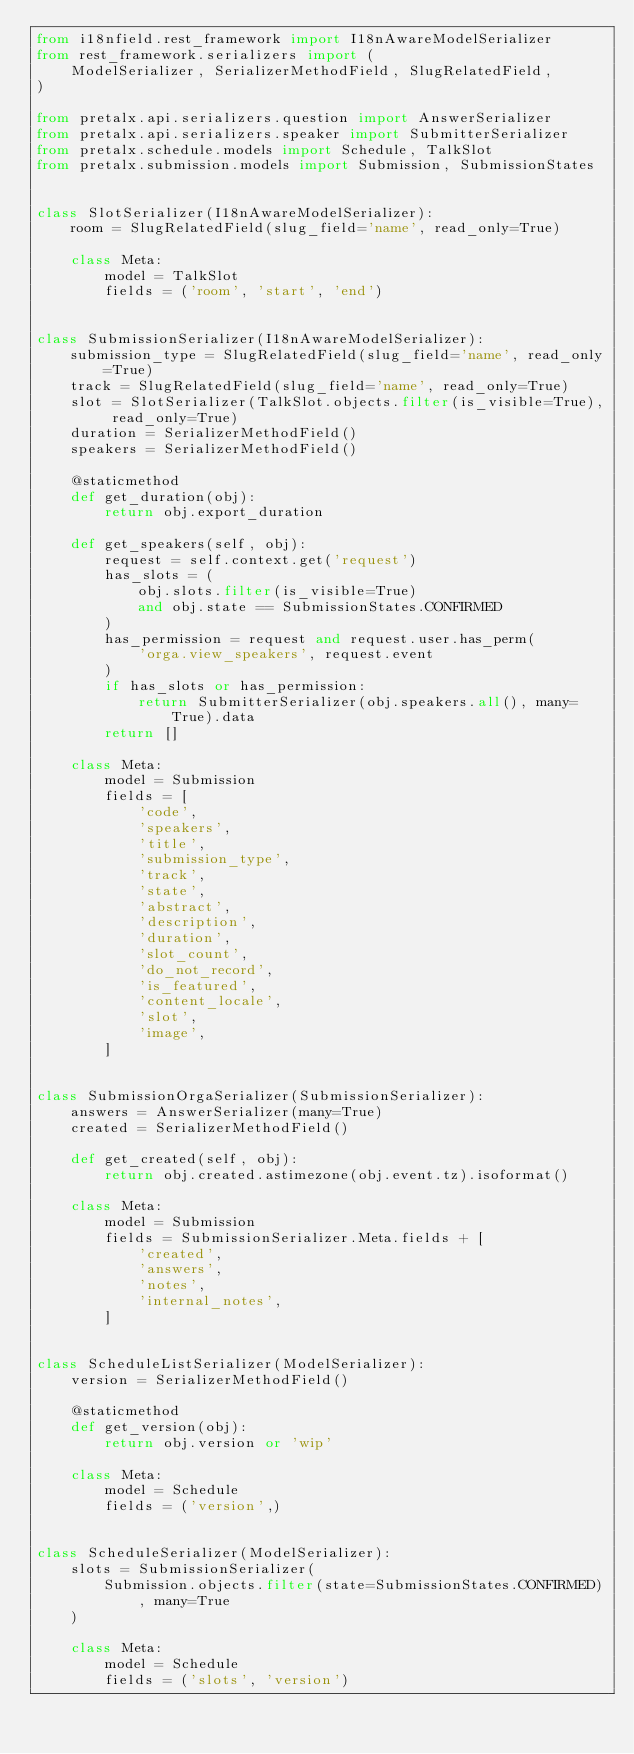Convert code to text. <code><loc_0><loc_0><loc_500><loc_500><_Python_>from i18nfield.rest_framework import I18nAwareModelSerializer
from rest_framework.serializers import (
    ModelSerializer, SerializerMethodField, SlugRelatedField,
)

from pretalx.api.serializers.question import AnswerSerializer
from pretalx.api.serializers.speaker import SubmitterSerializer
from pretalx.schedule.models import Schedule, TalkSlot
from pretalx.submission.models import Submission, SubmissionStates


class SlotSerializer(I18nAwareModelSerializer):
    room = SlugRelatedField(slug_field='name', read_only=True)

    class Meta:
        model = TalkSlot
        fields = ('room', 'start', 'end')


class SubmissionSerializer(I18nAwareModelSerializer):
    submission_type = SlugRelatedField(slug_field='name', read_only=True)
    track = SlugRelatedField(slug_field='name', read_only=True)
    slot = SlotSerializer(TalkSlot.objects.filter(is_visible=True), read_only=True)
    duration = SerializerMethodField()
    speakers = SerializerMethodField()

    @staticmethod
    def get_duration(obj):
        return obj.export_duration

    def get_speakers(self, obj):
        request = self.context.get('request')
        has_slots = (
            obj.slots.filter(is_visible=True)
            and obj.state == SubmissionStates.CONFIRMED
        )
        has_permission = request and request.user.has_perm(
            'orga.view_speakers', request.event
        )
        if has_slots or has_permission:
            return SubmitterSerializer(obj.speakers.all(), many=True).data
        return []

    class Meta:
        model = Submission
        fields = [
            'code',
            'speakers',
            'title',
            'submission_type',
            'track',
            'state',
            'abstract',
            'description',
            'duration',
            'slot_count',
            'do_not_record',
            'is_featured',
            'content_locale',
            'slot',
            'image',
        ]


class SubmissionOrgaSerializer(SubmissionSerializer):
    answers = AnswerSerializer(many=True)
    created = SerializerMethodField()

    def get_created(self, obj):
        return obj.created.astimezone(obj.event.tz).isoformat()

    class Meta:
        model = Submission
        fields = SubmissionSerializer.Meta.fields + [
            'created',
            'answers',
            'notes',
            'internal_notes',
        ]


class ScheduleListSerializer(ModelSerializer):
    version = SerializerMethodField()

    @staticmethod
    def get_version(obj):
        return obj.version or 'wip'

    class Meta:
        model = Schedule
        fields = ('version',)


class ScheduleSerializer(ModelSerializer):
    slots = SubmissionSerializer(
        Submission.objects.filter(state=SubmissionStates.CONFIRMED), many=True
    )

    class Meta:
        model = Schedule
        fields = ('slots', 'version')
</code> 